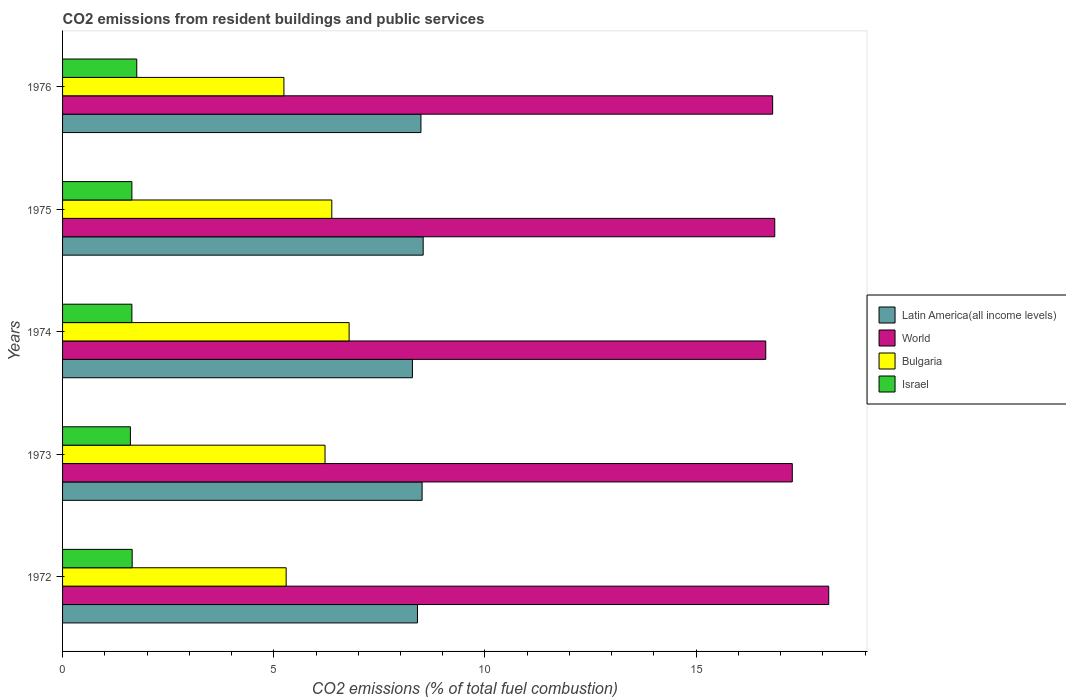How many different coloured bars are there?
Your response must be concise. 4. How many groups of bars are there?
Keep it short and to the point. 5. Are the number of bars on each tick of the Y-axis equal?
Provide a short and direct response. Yes. How many bars are there on the 4th tick from the top?
Make the answer very short. 4. How many bars are there on the 3rd tick from the bottom?
Your answer should be compact. 4. What is the total CO2 emitted in Israel in 1974?
Your answer should be compact. 1.64. Across all years, what is the maximum total CO2 emitted in Latin America(all income levels)?
Make the answer very short. 8.54. Across all years, what is the minimum total CO2 emitted in Israel?
Your answer should be very brief. 1.61. In which year was the total CO2 emitted in Bulgaria maximum?
Offer a very short reply. 1974. What is the total total CO2 emitted in Latin America(all income levels) in the graph?
Give a very brief answer. 42.22. What is the difference between the total CO2 emitted in Israel in 1972 and that in 1976?
Provide a succinct answer. -0.11. What is the difference between the total CO2 emitted in World in 1973 and the total CO2 emitted in Israel in 1976?
Your response must be concise. 15.52. What is the average total CO2 emitted in Israel per year?
Offer a terse response. 1.66. In the year 1976, what is the difference between the total CO2 emitted in Israel and total CO2 emitted in Latin America(all income levels)?
Give a very brief answer. -6.73. What is the ratio of the total CO2 emitted in Bulgaria in 1972 to that in 1974?
Your response must be concise. 0.78. Is the difference between the total CO2 emitted in Israel in 1975 and 1976 greater than the difference between the total CO2 emitted in Latin America(all income levels) in 1975 and 1976?
Provide a short and direct response. No. What is the difference between the highest and the second highest total CO2 emitted in World?
Make the answer very short. 0.86. What is the difference between the highest and the lowest total CO2 emitted in World?
Offer a terse response. 1.49. In how many years, is the total CO2 emitted in Latin America(all income levels) greater than the average total CO2 emitted in Latin America(all income levels) taken over all years?
Keep it short and to the point. 3. What does the 1st bar from the bottom in 1976 represents?
Make the answer very short. Latin America(all income levels). Is it the case that in every year, the sum of the total CO2 emitted in Bulgaria and total CO2 emitted in World is greater than the total CO2 emitted in Israel?
Provide a short and direct response. Yes. How many bars are there?
Your answer should be very brief. 20. How many years are there in the graph?
Give a very brief answer. 5. What is the difference between two consecutive major ticks on the X-axis?
Offer a terse response. 5. Does the graph contain any zero values?
Keep it short and to the point. No. Does the graph contain grids?
Keep it short and to the point. No. What is the title of the graph?
Give a very brief answer. CO2 emissions from resident buildings and public services. What is the label or title of the X-axis?
Offer a terse response. CO2 emissions (% of total fuel combustion). What is the label or title of the Y-axis?
Make the answer very short. Years. What is the CO2 emissions (% of total fuel combustion) in Latin America(all income levels) in 1972?
Keep it short and to the point. 8.4. What is the CO2 emissions (% of total fuel combustion) in World in 1972?
Make the answer very short. 18.14. What is the CO2 emissions (% of total fuel combustion) of Bulgaria in 1972?
Ensure brevity in your answer.  5.29. What is the CO2 emissions (% of total fuel combustion) in Israel in 1972?
Make the answer very short. 1.65. What is the CO2 emissions (% of total fuel combustion) in Latin America(all income levels) in 1973?
Your response must be concise. 8.51. What is the CO2 emissions (% of total fuel combustion) of World in 1973?
Your answer should be very brief. 17.28. What is the CO2 emissions (% of total fuel combustion) in Bulgaria in 1973?
Keep it short and to the point. 6.21. What is the CO2 emissions (% of total fuel combustion) in Israel in 1973?
Provide a succinct answer. 1.61. What is the CO2 emissions (% of total fuel combustion) in Latin America(all income levels) in 1974?
Keep it short and to the point. 8.28. What is the CO2 emissions (% of total fuel combustion) of World in 1974?
Offer a terse response. 16.65. What is the CO2 emissions (% of total fuel combustion) in Bulgaria in 1974?
Provide a short and direct response. 6.78. What is the CO2 emissions (% of total fuel combustion) of Israel in 1974?
Offer a very short reply. 1.64. What is the CO2 emissions (% of total fuel combustion) in Latin America(all income levels) in 1975?
Offer a very short reply. 8.54. What is the CO2 emissions (% of total fuel combustion) in World in 1975?
Offer a terse response. 16.86. What is the CO2 emissions (% of total fuel combustion) in Bulgaria in 1975?
Provide a succinct answer. 6.37. What is the CO2 emissions (% of total fuel combustion) of Israel in 1975?
Keep it short and to the point. 1.64. What is the CO2 emissions (% of total fuel combustion) in Latin America(all income levels) in 1976?
Your answer should be compact. 8.48. What is the CO2 emissions (% of total fuel combustion) in World in 1976?
Provide a succinct answer. 16.81. What is the CO2 emissions (% of total fuel combustion) of Bulgaria in 1976?
Your answer should be compact. 5.24. What is the CO2 emissions (% of total fuel combustion) of Israel in 1976?
Your response must be concise. 1.76. Across all years, what is the maximum CO2 emissions (% of total fuel combustion) of Latin America(all income levels)?
Provide a short and direct response. 8.54. Across all years, what is the maximum CO2 emissions (% of total fuel combustion) in World?
Ensure brevity in your answer.  18.14. Across all years, what is the maximum CO2 emissions (% of total fuel combustion) in Bulgaria?
Provide a short and direct response. 6.78. Across all years, what is the maximum CO2 emissions (% of total fuel combustion) in Israel?
Provide a succinct answer. 1.76. Across all years, what is the minimum CO2 emissions (% of total fuel combustion) in Latin America(all income levels)?
Keep it short and to the point. 8.28. Across all years, what is the minimum CO2 emissions (% of total fuel combustion) of World?
Offer a very short reply. 16.65. Across all years, what is the minimum CO2 emissions (% of total fuel combustion) of Bulgaria?
Your answer should be compact. 5.24. Across all years, what is the minimum CO2 emissions (% of total fuel combustion) of Israel?
Offer a terse response. 1.61. What is the total CO2 emissions (% of total fuel combustion) in Latin America(all income levels) in the graph?
Ensure brevity in your answer.  42.22. What is the total CO2 emissions (% of total fuel combustion) of World in the graph?
Make the answer very short. 85.73. What is the total CO2 emissions (% of total fuel combustion) of Bulgaria in the graph?
Make the answer very short. 29.9. What is the total CO2 emissions (% of total fuel combustion) of Israel in the graph?
Your answer should be compact. 8.29. What is the difference between the CO2 emissions (% of total fuel combustion) of Latin America(all income levels) in 1972 and that in 1973?
Your answer should be compact. -0.11. What is the difference between the CO2 emissions (% of total fuel combustion) of World in 1972 and that in 1973?
Provide a short and direct response. 0.86. What is the difference between the CO2 emissions (% of total fuel combustion) of Bulgaria in 1972 and that in 1973?
Your answer should be very brief. -0.92. What is the difference between the CO2 emissions (% of total fuel combustion) of Israel in 1972 and that in 1973?
Provide a short and direct response. 0.04. What is the difference between the CO2 emissions (% of total fuel combustion) of Latin America(all income levels) in 1972 and that in 1974?
Offer a very short reply. 0.12. What is the difference between the CO2 emissions (% of total fuel combustion) in World in 1972 and that in 1974?
Give a very brief answer. 1.49. What is the difference between the CO2 emissions (% of total fuel combustion) of Bulgaria in 1972 and that in 1974?
Keep it short and to the point. -1.49. What is the difference between the CO2 emissions (% of total fuel combustion) of Israel in 1972 and that in 1974?
Provide a succinct answer. 0.01. What is the difference between the CO2 emissions (% of total fuel combustion) of Latin America(all income levels) in 1972 and that in 1975?
Offer a very short reply. -0.14. What is the difference between the CO2 emissions (% of total fuel combustion) in World in 1972 and that in 1975?
Make the answer very short. 1.28. What is the difference between the CO2 emissions (% of total fuel combustion) in Bulgaria in 1972 and that in 1975?
Offer a very short reply. -1.08. What is the difference between the CO2 emissions (% of total fuel combustion) in Israel in 1972 and that in 1975?
Your answer should be very brief. 0.01. What is the difference between the CO2 emissions (% of total fuel combustion) in Latin America(all income levels) in 1972 and that in 1976?
Provide a succinct answer. -0.08. What is the difference between the CO2 emissions (% of total fuel combustion) in World in 1972 and that in 1976?
Give a very brief answer. 1.33. What is the difference between the CO2 emissions (% of total fuel combustion) of Bulgaria in 1972 and that in 1976?
Offer a terse response. 0.05. What is the difference between the CO2 emissions (% of total fuel combustion) in Israel in 1972 and that in 1976?
Offer a very short reply. -0.11. What is the difference between the CO2 emissions (% of total fuel combustion) of Latin America(all income levels) in 1973 and that in 1974?
Your response must be concise. 0.23. What is the difference between the CO2 emissions (% of total fuel combustion) of World in 1973 and that in 1974?
Offer a terse response. 0.63. What is the difference between the CO2 emissions (% of total fuel combustion) of Bulgaria in 1973 and that in 1974?
Ensure brevity in your answer.  -0.57. What is the difference between the CO2 emissions (% of total fuel combustion) of Israel in 1973 and that in 1974?
Provide a short and direct response. -0.04. What is the difference between the CO2 emissions (% of total fuel combustion) of Latin America(all income levels) in 1973 and that in 1975?
Keep it short and to the point. -0.03. What is the difference between the CO2 emissions (% of total fuel combustion) of World in 1973 and that in 1975?
Provide a short and direct response. 0.42. What is the difference between the CO2 emissions (% of total fuel combustion) in Bulgaria in 1973 and that in 1975?
Offer a very short reply. -0.16. What is the difference between the CO2 emissions (% of total fuel combustion) in Israel in 1973 and that in 1975?
Your response must be concise. -0.04. What is the difference between the CO2 emissions (% of total fuel combustion) of Latin America(all income levels) in 1973 and that in 1976?
Keep it short and to the point. 0.03. What is the difference between the CO2 emissions (% of total fuel combustion) of World in 1973 and that in 1976?
Provide a short and direct response. 0.47. What is the difference between the CO2 emissions (% of total fuel combustion) in Bulgaria in 1973 and that in 1976?
Keep it short and to the point. 0.97. What is the difference between the CO2 emissions (% of total fuel combustion) of Israel in 1973 and that in 1976?
Your response must be concise. -0.15. What is the difference between the CO2 emissions (% of total fuel combustion) of Latin America(all income levels) in 1974 and that in 1975?
Your answer should be very brief. -0.25. What is the difference between the CO2 emissions (% of total fuel combustion) of World in 1974 and that in 1975?
Make the answer very short. -0.21. What is the difference between the CO2 emissions (% of total fuel combustion) in Bulgaria in 1974 and that in 1975?
Ensure brevity in your answer.  0.41. What is the difference between the CO2 emissions (% of total fuel combustion) in Latin America(all income levels) in 1974 and that in 1976?
Provide a short and direct response. -0.2. What is the difference between the CO2 emissions (% of total fuel combustion) in World in 1974 and that in 1976?
Provide a succinct answer. -0.16. What is the difference between the CO2 emissions (% of total fuel combustion) in Bulgaria in 1974 and that in 1976?
Offer a terse response. 1.54. What is the difference between the CO2 emissions (% of total fuel combustion) in Israel in 1974 and that in 1976?
Your answer should be compact. -0.12. What is the difference between the CO2 emissions (% of total fuel combustion) of Latin America(all income levels) in 1975 and that in 1976?
Your answer should be very brief. 0.05. What is the difference between the CO2 emissions (% of total fuel combustion) of World in 1975 and that in 1976?
Keep it short and to the point. 0.05. What is the difference between the CO2 emissions (% of total fuel combustion) in Bulgaria in 1975 and that in 1976?
Provide a succinct answer. 1.13. What is the difference between the CO2 emissions (% of total fuel combustion) of Israel in 1975 and that in 1976?
Make the answer very short. -0.12. What is the difference between the CO2 emissions (% of total fuel combustion) in Latin America(all income levels) in 1972 and the CO2 emissions (% of total fuel combustion) in World in 1973?
Offer a very short reply. -8.87. What is the difference between the CO2 emissions (% of total fuel combustion) of Latin America(all income levels) in 1972 and the CO2 emissions (% of total fuel combustion) of Bulgaria in 1973?
Provide a succinct answer. 2.19. What is the difference between the CO2 emissions (% of total fuel combustion) in Latin America(all income levels) in 1972 and the CO2 emissions (% of total fuel combustion) in Israel in 1973?
Your answer should be very brief. 6.8. What is the difference between the CO2 emissions (% of total fuel combustion) of World in 1972 and the CO2 emissions (% of total fuel combustion) of Bulgaria in 1973?
Your answer should be compact. 11.92. What is the difference between the CO2 emissions (% of total fuel combustion) of World in 1972 and the CO2 emissions (% of total fuel combustion) of Israel in 1973?
Make the answer very short. 16.53. What is the difference between the CO2 emissions (% of total fuel combustion) in Bulgaria in 1972 and the CO2 emissions (% of total fuel combustion) in Israel in 1973?
Give a very brief answer. 3.69. What is the difference between the CO2 emissions (% of total fuel combustion) of Latin America(all income levels) in 1972 and the CO2 emissions (% of total fuel combustion) of World in 1974?
Your answer should be very brief. -8.25. What is the difference between the CO2 emissions (% of total fuel combustion) in Latin America(all income levels) in 1972 and the CO2 emissions (% of total fuel combustion) in Bulgaria in 1974?
Your response must be concise. 1.62. What is the difference between the CO2 emissions (% of total fuel combustion) in Latin America(all income levels) in 1972 and the CO2 emissions (% of total fuel combustion) in Israel in 1974?
Offer a terse response. 6.76. What is the difference between the CO2 emissions (% of total fuel combustion) in World in 1972 and the CO2 emissions (% of total fuel combustion) in Bulgaria in 1974?
Make the answer very short. 11.35. What is the difference between the CO2 emissions (% of total fuel combustion) in World in 1972 and the CO2 emissions (% of total fuel combustion) in Israel in 1974?
Ensure brevity in your answer.  16.5. What is the difference between the CO2 emissions (% of total fuel combustion) of Bulgaria in 1972 and the CO2 emissions (% of total fuel combustion) of Israel in 1974?
Make the answer very short. 3.65. What is the difference between the CO2 emissions (% of total fuel combustion) of Latin America(all income levels) in 1972 and the CO2 emissions (% of total fuel combustion) of World in 1975?
Your response must be concise. -8.46. What is the difference between the CO2 emissions (% of total fuel combustion) in Latin America(all income levels) in 1972 and the CO2 emissions (% of total fuel combustion) in Bulgaria in 1975?
Your answer should be very brief. 2.03. What is the difference between the CO2 emissions (% of total fuel combustion) of Latin America(all income levels) in 1972 and the CO2 emissions (% of total fuel combustion) of Israel in 1975?
Provide a succinct answer. 6.76. What is the difference between the CO2 emissions (% of total fuel combustion) of World in 1972 and the CO2 emissions (% of total fuel combustion) of Bulgaria in 1975?
Your answer should be very brief. 11.76. What is the difference between the CO2 emissions (% of total fuel combustion) of World in 1972 and the CO2 emissions (% of total fuel combustion) of Israel in 1975?
Ensure brevity in your answer.  16.5. What is the difference between the CO2 emissions (% of total fuel combustion) in Bulgaria in 1972 and the CO2 emissions (% of total fuel combustion) in Israel in 1975?
Offer a very short reply. 3.65. What is the difference between the CO2 emissions (% of total fuel combustion) in Latin America(all income levels) in 1972 and the CO2 emissions (% of total fuel combustion) in World in 1976?
Keep it short and to the point. -8.41. What is the difference between the CO2 emissions (% of total fuel combustion) of Latin America(all income levels) in 1972 and the CO2 emissions (% of total fuel combustion) of Bulgaria in 1976?
Your answer should be very brief. 3.16. What is the difference between the CO2 emissions (% of total fuel combustion) of Latin America(all income levels) in 1972 and the CO2 emissions (% of total fuel combustion) of Israel in 1976?
Keep it short and to the point. 6.65. What is the difference between the CO2 emissions (% of total fuel combustion) in World in 1972 and the CO2 emissions (% of total fuel combustion) in Bulgaria in 1976?
Your response must be concise. 12.9. What is the difference between the CO2 emissions (% of total fuel combustion) in World in 1972 and the CO2 emissions (% of total fuel combustion) in Israel in 1976?
Provide a short and direct response. 16.38. What is the difference between the CO2 emissions (% of total fuel combustion) of Bulgaria in 1972 and the CO2 emissions (% of total fuel combustion) of Israel in 1976?
Your answer should be very brief. 3.54. What is the difference between the CO2 emissions (% of total fuel combustion) in Latin America(all income levels) in 1973 and the CO2 emissions (% of total fuel combustion) in World in 1974?
Give a very brief answer. -8.14. What is the difference between the CO2 emissions (% of total fuel combustion) of Latin America(all income levels) in 1973 and the CO2 emissions (% of total fuel combustion) of Bulgaria in 1974?
Your response must be concise. 1.73. What is the difference between the CO2 emissions (% of total fuel combustion) of Latin America(all income levels) in 1973 and the CO2 emissions (% of total fuel combustion) of Israel in 1974?
Ensure brevity in your answer.  6.87. What is the difference between the CO2 emissions (% of total fuel combustion) of World in 1973 and the CO2 emissions (% of total fuel combustion) of Bulgaria in 1974?
Your response must be concise. 10.49. What is the difference between the CO2 emissions (% of total fuel combustion) in World in 1973 and the CO2 emissions (% of total fuel combustion) in Israel in 1974?
Offer a terse response. 15.63. What is the difference between the CO2 emissions (% of total fuel combustion) in Bulgaria in 1973 and the CO2 emissions (% of total fuel combustion) in Israel in 1974?
Your response must be concise. 4.57. What is the difference between the CO2 emissions (% of total fuel combustion) in Latin America(all income levels) in 1973 and the CO2 emissions (% of total fuel combustion) in World in 1975?
Your answer should be very brief. -8.35. What is the difference between the CO2 emissions (% of total fuel combustion) in Latin America(all income levels) in 1973 and the CO2 emissions (% of total fuel combustion) in Bulgaria in 1975?
Your response must be concise. 2.14. What is the difference between the CO2 emissions (% of total fuel combustion) in Latin America(all income levels) in 1973 and the CO2 emissions (% of total fuel combustion) in Israel in 1975?
Offer a terse response. 6.87. What is the difference between the CO2 emissions (% of total fuel combustion) of World in 1973 and the CO2 emissions (% of total fuel combustion) of Bulgaria in 1975?
Your response must be concise. 10.9. What is the difference between the CO2 emissions (% of total fuel combustion) of World in 1973 and the CO2 emissions (% of total fuel combustion) of Israel in 1975?
Keep it short and to the point. 15.63. What is the difference between the CO2 emissions (% of total fuel combustion) in Bulgaria in 1973 and the CO2 emissions (% of total fuel combustion) in Israel in 1975?
Make the answer very short. 4.57. What is the difference between the CO2 emissions (% of total fuel combustion) in Latin America(all income levels) in 1973 and the CO2 emissions (% of total fuel combustion) in World in 1976?
Ensure brevity in your answer.  -8.3. What is the difference between the CO2 emissions (% of total fuel combustion) of Latin America(all income levels) in 1973 and the CO2 emissions (% of total fuel combustion) of Bulgaria in 1976?
Offer a very short reply. 3.27. What is the difference between the CO2 emissions (% of total fuel combustion) of Latin America(all income levels) in 1973 and the CO2 emissions (% of total fuel combustion) of Israel in 1976?
Make the answer very short. 6.76. What is the difference between the CO2 emissions (% of total fuel combustion) in World in 1973 and the CO2 emissions (% of total fuel combustion) in Bulgaria in 1976?
Ensure brevity in your answer.  12.04. What is the difference between the CO2 emissions (% of total fuel combustion) of World in 1973 and the CO2 emissions (% of total fuel combustion) of Israel in 1976?
Keep it short and to the point. 15.52. What is the difference between the CO2 emissions (% of total fuel combustion) of Bulgaria in 1973 and the CO2 emissions (% of total fuel combustion) of Israel in 1976?
Provide a short and direct response. 4.46. What is the difference between the CO2 emissions (% of total fuel combustion) in Latin America(all income levels) in 1974 and the CO2 emissions (% of total fuel combustion) in World in 1975?
Provide a succinct answer. -8.58. What is the difference between the CO2 emissions (% of total fuel combustion) of Latin America(all income levels) in 1974 and the CO2 emissions (% of total fuel combustion) of Bulgaria in 1975?
Offer a very short reply. 1.91. What is the difference between the CO2 emissions (% of total fuel combustion) of Latin America(all income levels) in 1974 and the CO2 emissions (% of total fuel combustion) of Israel in 1975?
Ensure brevity in your answer.  6.64. What is the difference between the CO2 emissions (% of total fuel combustion) in World in 1974 and the CO2 emissions (% of total fuel combustion) in Bulgaria in 1975?
Offer a terse response. 10.27. What is the difference between the CO2 emissions (% of total fuel combustion) in World in 1974 and the CO2 emissions (% of total fuel combustion) in Israel in 1975?
Provide a succinct answer. 15.01. What is the difference between the CO2 emissions (% of total fuel combustion) in Bulgaria in 1974 and the CO2 emissions (% of total fuel combustion) in Israel in 1975?
Provide a succinct answer. 5.14. What is the difference between the CO2 emissions (% of total fuel combustion) of Latin America(all income levels) in 1974 and the CO2 emissions (% of total fuel combustion) of World in 1976?
Keep it short and to the point. -8.53. What is the difference between the CO2 emissions (% of total fuel combustion) in Latin America(all income levels) in 1974 and the CO2 emissions (% of total fuel combustion) in Bulgaria in 1976?
Keep it short and to the point. 3.04. What is the difference between the CO2 emissions (% of total fuel combustion) in Latin America(all income levels) in 1974 and the CO2 emissions (% of total fuel combustion) in Israel in 1976?
Offer a terse response. 6.53. What is the difference between the CO2 emissions (% of total fuel combustion) in World in 1974 and the CO2 emissions (% of total fuel combustion) in Bulgaria in 1976?
Provide a short and direct response. 11.41. What is the difference between the CO2 emissions (% of total fuel combustion) of World in 1974 and the CO2 emissions (% of total fuel combustion) of Israel in 1976?
Provide a short and direct response. 14.89. What is the difference between the CO2 emissions (% of total fuel combustion) of Bulgaria in 1974 and the CO2 emissions (% of total fuel combustion) of Israel in 1976?
Give a very brief answer. 5.03. What is the difference between the CO2 emissions (% of total fuel combustion) of Latin America(all income levels) in 1975 and the CO2 emissions (% of total fuel combustion) of World in 1976?
Offer a very short reply. -8.27. What is the difference between the CO2 emissions (% of total fuel combustion) in Latin America(all income levels) in 1975 and the CO2 emissions (% of total fuel combustion) in Bulgaria in 1976?
Ensure brevity in your answer.  3.3. What is the difference between the CO2 emissions (% of total fuel combustion) of Latin America(all income levels) in 1975 and the CO2 emissions (% of total fuel combustion) of Israel in 1976?
Keep it short and to the point. 6.78. What is the difference between the CO2 emissions (% of total fuel combustion) in World in 1975 and the CO2 emissions (% of total fuel combustion) in Bulgaria in 1976?
Keep it short and to the point. 11.62. What is the difference between the CO2 emissions (% of total fuel combustion) of World in 1975 and the CO2 emissions (% of total fuel combustion) of Israel in 1976?
Make the answer very short. 15.1. What is the difference between the CO2 emissions (% of total fuel combustion) in Bulgaria in 1975 and the CO2 emissions (% of total fuel combustion) in Israel in 1976?
Make the answer very short. 4.62. What is the average CO2 emissions (% of total fuel combustion) in Latin America(all income levels) per year?
Ensure brevity in your answer.  8.44. What is the average CO2 emissions (% of total fuel combustion) in World per year?
Offer a very short reply. 17.15. What is the average CO2 emissions (% of total fuel combustion) in Bulgaria per year?
Give a very brief answer. 5.98. What is the average CO2 emissions (% of total fuel combustion) in Israel per year?
Your answer should be compact. 1.66. In the year 1972, what is the difference between the CO2 emissions (% of total fuel combustion) in Latin America(all income levels) and CO2 emissions (% of total fuel combustion) in World?
Offer a very short reply. -9.74. In the year 1972, what is the difference between the CO2 emissions (% of total fuel combustion) of Latin America(all income levels) and CO2 emissions (% of total fuel combustion) of Bulgaria?
Ensure brevity in your answer.  3.11. In the year 1972, what is the difference between the CO2 emissions (% of total fuel combustion) of Latin America(all income levels) and CO2 emissions (% of total fuel combustion) of Israel?
Offer a very short reply. 6.75. In the year 1972, what is the difference between the CO2 emissions (% of total fuel combustion) in World and CO2 emissions (% of total fuel combustion) in Bulgaria?
Offer a very short reply. 12.85. In the year 1972, what is the difference between the CO2 emissions (% of total fuel combustion) of World and CO2 emissions (% of total fuel combustion) of Israel?
Ensure brevity in your answer.  16.49. In the year 1972, what is the difference between the CO2 emissions (% of total fuel combustion) of Bulgaria and CO2 emissions (% of total fuel combustion) of Israel?
Offer a very short reply. 3.65. In the year 1973, what is the difference between the CO2 emissions (% of total fuel combustion) in Latin America(all income levels) and CO2 emissions (% of total fuel combustion) in World?
Give a very brief answer. -8.76. In the year 1973, what is the difference between the CO2 emissions (% of total fuel combustion) of Latin America(all income levels) and CO2 emissions (% of total fuel combustion) of Bulgaria?
Offer a very short reply. 2.3. In the year 1973, what is the difference between the CO2 emissions (% of total fuel combustion) of Latin America(all income levels) and CO2 emissions (% of total fuel combustion) of Israel?
Keep it short and to the point. 6.91. In the year 1973, what is the difference between the CO2 emissions (% of total fuel combustion) of World and CO2 emissions (% of total fuel combustion) of Bulgaria?
Your answer should be compact. 11.06. In the year 1973, what is the difference between the CO2 emissions (% of total fuel combustion) of World and CO2 emissions (% of total fuel combustion) of Israel?
Provide a short and direct response. 15.67. In the year 1973, what is the difference between the CO2 emissions (% of total fuel combustion) of Bulgaria and CO2 emissions (% of total fuel combustion) of Israel?
Keep it short and to the point. 4.61. In the year 1974, what is the difference between the CO2 emissions (% of total fuel combustion) of Latin America(all income levels) and CO2 emissions (% of total fuel combustion) of World?
Give a very brief answer. -8.36. In the year 1974, what is the difference between the CO2 emissions (% of total fuel combustion) of Latin America(all income levels) and CO2 emissions (% of total fuel combustion) of Bulgaria?
Ensure brevity in your answer.  1.5. In the year 1974, what is the difference between the CO2 emissions (% of total fuel combustion) in Latin America(all income levels) and CO2 emissions (% of total fuel combustion) in Israel?
Provide a short and direct response. 6.64. In the year 1974, what is the difference between the CO2 emissions (% of total fuel combustion) of World and CO2 emissions (% of total fuel combustion) of Bulgaria?
Give a very brief answer. 9.86. In the year 1974, what is the difference between the CO2 emissions (% of total fuel combustion) of World and CO2 emissions (% of total fuel combustion) of Israel?
Provide a short and direct response. 15.01. In the year 1974, what is the difference between the CO2 emissions (% of total fuel combustion) in Bulgaria and CO2 emissions (% of total fuel combustion) in Israel?
Give a very brief answer. 5.14. In the year 1975, what is the difference between the CO2 emissions (% of total fuel combustion) of Latin America(all income levels) and CO2 emissions (% of total fuel combustion) of World?
Offer a terse response. -8.32. In the year 1975, what is the difference between the CO2 emissions (% of total fuel combustion) of Latin America(all income levels) and CO2 emissions (% of total fuel combustion) of Bulgaria?
Make the answer very short. 2.16. In the year 1975, what is the difference between the CO2 emissions (% of total fuel combustion) of Latin America(all income levels) and CO2 emissions (% of total fuel combustion) of Israel?
Keep it short and to the point. 6.9. In the year 1975, what is the difference between the CO2 emissions (% of total fuel combustion) in World and CO2 emissions (% of total fuel combustion) in Bulgaria?
Keep it short and to the point. 10.49. In the year 1975, what is the difference between the CO2 emissions (% of total fuel combustion) in World and CO2 emissions (% of total fuel combustion) in Israel?
Provide a succinct answer. 15.22. In the year 1975, what is the difference between the CO2 emissions (% of total fuel combustion) in Bulgaria and CO2 emissions (% of total fuel combustion) in Israel?
Your answer should be compact. 4.73. In the year 1976, what is the difference between the CO2 emissions (% of total fuel combustion) in Latin America(all income levels) and CO2 emissions (% of total fuel combustion) in World?
Your response must be concise. -8.33. In the year 1976, what is the difference between the CO2 emissions (% of total fuel combustion) in Latin America(all income levels) and CO2 emissions (% of total fuel combustion) in Bulgaria?
Offer a terse response. 3.24. In the year 1976, what is the difference between the CO2 emissions (% of total fuel combustion) in Latin America(all income levels) and CO2 emissions (% of total fuel combustion) in Israel?
Provide a short and direct response. 6.73. In the year 1976, what is the difference between the CO2 emissions (% of total fuel combustion) of World and CO2 emissions (% of total fuel combustion) of Bulgaria?
Offer a very short reply. 11.57. In the year 1976, what is the difference between the CO2 emissions (% of total fuel combustion) in World and CO2 emissions (% of total fuel combustion) in Israel?
Ensure brevity in your answer.  15.05. In the year 1976, what is the difference between the CO2 emissions (% of total fuel combustion) in Bulgaria and CO2 emissions (% of total fuel combustion) in Israel?
Ensure brevity in your answer.  3.48. What is the ratio of the CO2 emissions (% of total fuel combustion) in Latin America(all income levels) in 1972 to that in 1973?
Offer a terse response. 0.99. What is the ratio of the CO2 emissions (% of total fuel combustion) of World in 1972 to that in 1973?
Offer a very short reply. 1.05. What is the ratio of the CO2 emissions (% of total fuel combustion) in Bulgaria in 1972 to that in 1973?
Offer a very short reply. 0.85. What is the ratio of the CO2 emissions (% of total fuel combustion) in Israel in 1972 to that in 1973?
Your response must be concise. 1.03. What is the ratio of the CO2 emissions (% of total fuel combustion) of Latin America(all income levels) in 1972 to that in 1974?
Ensure brevity in your answer.  1.01. What is the ratio of the CO2 emissions (% of total fuel combustion) of World in 1972 to that in 1974?
Provide a succinct answer. 1.09. What is the ratio of the CO2 emissions (% of total fuel combustion) of Bulgaria in 1972 to that in 1974?
Keep it short and to the point. 0.78. What is the ratio of the CO2 emissions (% of total fuel combustion) in Israel in 1972 to that in 1974?
Your answer should be compact. 1. What is the ratio of the CO2 emissions (% of total fuel combustion) of Latin America(all income levels) in 1972 to that in 1975?
Offer a terse response. 0.98. What is the ratio of the CO2 emissions (% of total fuel combustion) of World in 1972 to that in 1975?
Your answer should be compact. 1.08. What is the ratio of the CO2 emissions (% of total fuel combustion) of Bulgaria in 1972 to that in 1975?
Make the answer very short. 0.83. What is the ratio of the CO2 emissions (% of total fuel combustion) in Latin America(all income levels) in 1972 to that in 1976?
Your answer should be compact. 0.99. What is the ratio of the CO2 emissions (% of total fuel combustion) in World in 1972 to that in 1976?
Your answer should be very brief. 1.08. What is the ratio of the CO2 emissions (% of total fuel combustion) in Bulgaria in 1972 to that in 1976?
Keep it short and to the point. 1.01. What is the ratio of the CO2 emissions (% of total fuel combustion) in Israel in 1972 to that in 1976?
Your answer should be very brief. 0.94. What is the ratio of the CO2 emissions (% of total fuel combustion) in Latin America(all income levels) in 1973 to that in 1974?
Make the answer very short. 1.03. What is the ratio of the CO2 emissions (% of total fuel combustion) of World in 1973 to that in 1974?
Provide a short and direct response. 1.04. What is the ratio of the CO2 emissions (% of total fuel combustion) in Bulgaria in 1973 to that in 1974?
Your answer should be compact. 0.92. What is the ratio of the CO2 emissions (% of total fuel combustion) of Israel in 1973 to that in 1974?
Keep it short and to the point. 0.98. What is the ratio of the CO2 emissions (% of total fuel combustion) in World in 1973 to that in 1975?
Make the answer very short. 1.02. What is the ratio of the CO2 emissions (% of total fuel combustion) in Bulgaria in 1973 to that in 1975?
Your answer should be compact. 0.97. What is the ratio of the CO2 emissions (% of total fuel combustion) of Israel in 1973 to that in 1975?
Your response must be concise. 0.98. What is the ratio of the CO2 emissions (% of total fuel combustion) of World in 1973 to that in 1976?
Your answer should be very brief. 1.03. What is the ratio of the CO2 emissions (% of total fuel combustion) of Bulgaria in 1973 to that in 1976?
Provide a short and direct response. 1.19. What is the ratio of the CO2 emissions (% of total fuel combustion) of Israel in 1973 to that in 1976?
Provide a short and direct response. 0.91. What is the ratio of the CO2 emissions (% of total fuel combustion) in Latin America(all income levels) in 1974 to that in 1975?
Your answer should be very brief. 0.97. What is the ratio of the CO2 emissions (% of total fuel combustion) in World in 1974 to that in 1975?
Give a very brief answer. 0.99. What is the ratio of the CO2 emissions (% of total fuel combustion) in Bulgaria in 1974 to that in 1975?
Provide a short and direct response. 1.06. What is the ratio of the CO2 emissions (% of total fuel combustion) in Israel in 1974 to that in 1975?
Provide a succinct answer. 1. What is the ratio of the CO2 emissions (% of total fuel combustion) of Latin America(all income levels) in 1974 to that in 1976?
Ensure brevity in your answer.  0.98. What is the ratio of the CO2 emissions (% of total fuel combustion) in World in 1974 to that in 1976?
Ensure brevity in your answer.  0.99. What is the ratio of the CO2 emissions (% of total fuel combustion) of Bulgaria in 1974 to that in 1976?
Keep it short and to the point. 1.29. What is the ratio of the CO2 emissions (% of total fuel combustion) of Israel in 1974 to that in 1976?
Offer a terse response. 0.93. What is the ratio of the CO2 emissions (% of total fuel combustion) of Latin America(all income levels) in 1975 to that in 1976?
Your response must be concise. 1.01. What is the ratio of the CO2 emissions (% of total fuel combustion) in Bulgaria in 1975 to that in 1976?
Make the answer very short. 1.22. What is the ratio of the CO2 emissions (% of total fuel combustion) of Israel in 1975 to that in 1976?
Make the answer very short. 0.93. What is the difference between the highest and the second highest CO2 emissions (% of total fuel combustion) in Latin America(all income levels)?
Provide a short and direct response. 0.03. What is the difference between the highest and the second highest CO2 emissions (% of total fuel combustion) of World?
Provide a succinct answer. 0.86. What is the difference between the highest and the second highest CO2 emissions (% of total fuel combustion) in Bulgaria?
Provide a short and direct response. 0.41. What is the difference between the highest and the second highest CO2 emissions (% of total fuel combustion) of Israel?
Ensure brevity in your answer.  0.11. What is the difference between the highest and the lowest CO2 emissions (% of total fuel combustion) in Latin America(all income levels)?
Your response must be concise. 0.25. What is the difference between the highest and the lowest CO2 emissions (% of total fuel combustion) of World?
Keep it short and to the point. 1.49. What is the difference between the highest and the lowest CO2 emissions (% of total fuel combustion) of Bulgaria?
Keep it short and to the point. 1.54. What is the difference between the highest and the lowest CO2 emissions (% of total fuel combustion) in Israel?
Give a very brief answer. 0.15. 